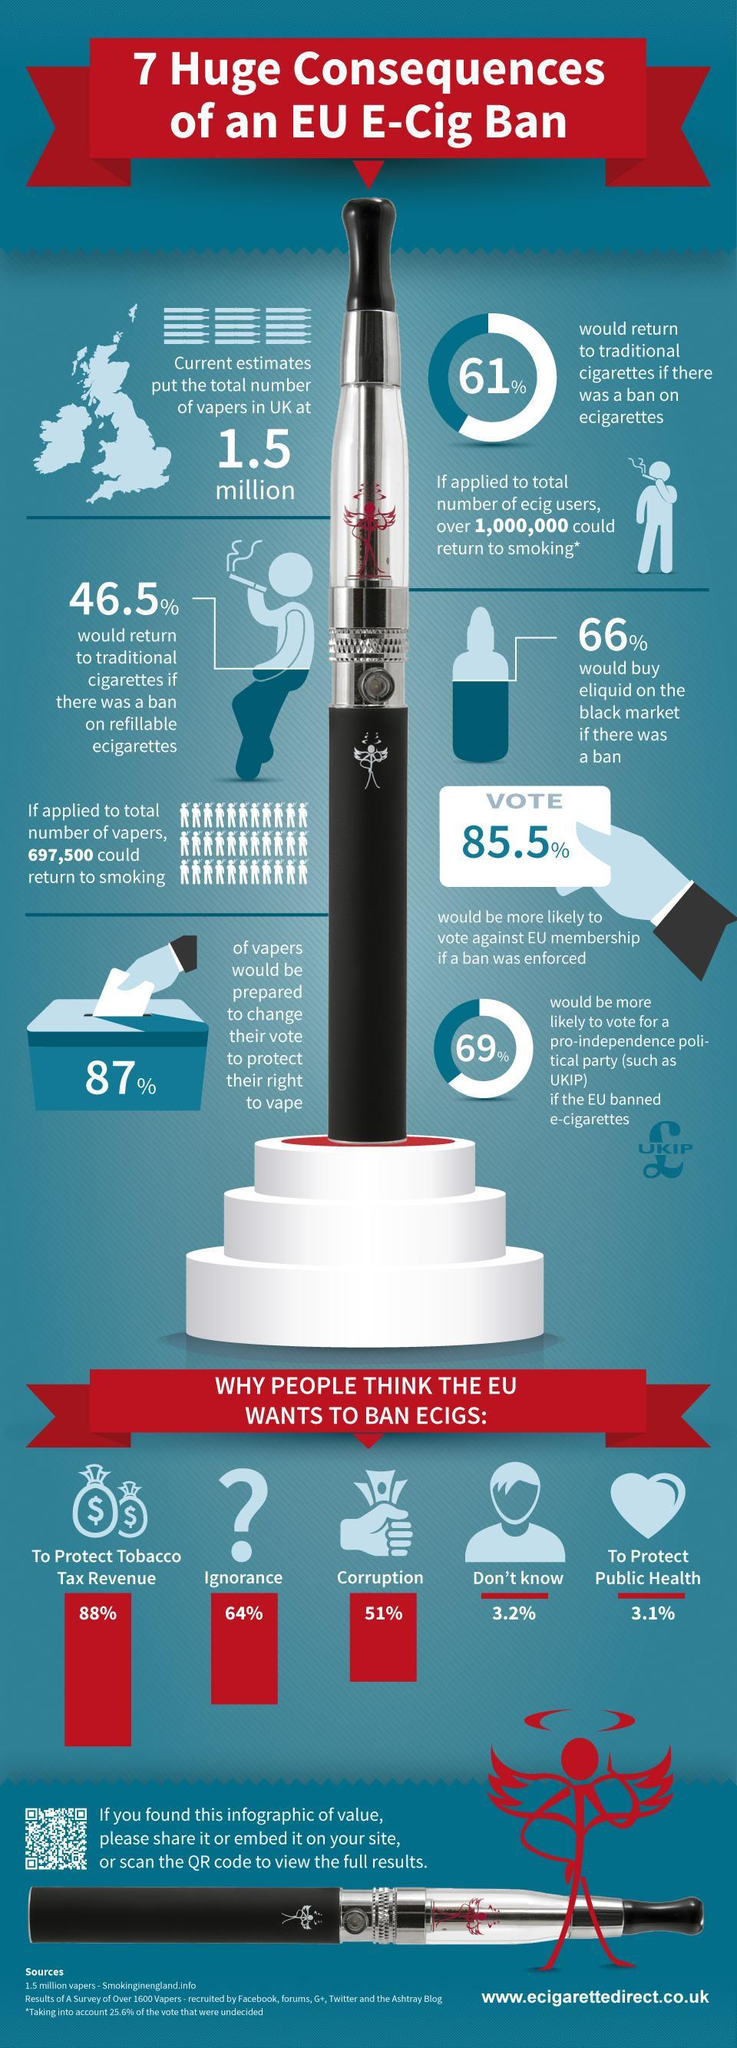What is the estimated total number of vapers in UK?
Answer the question with a short phrase. 1.5 million What percentage of people think that EU wants to ban e-cigarettes in order to protect public health? 3.1% What percentage of people think that EU wants to ban e-cigarettes due to corruption? 51% What percentage of people think that EU wants to ban e-cigarettes in order to protect tobacco tax revenue? 88% 